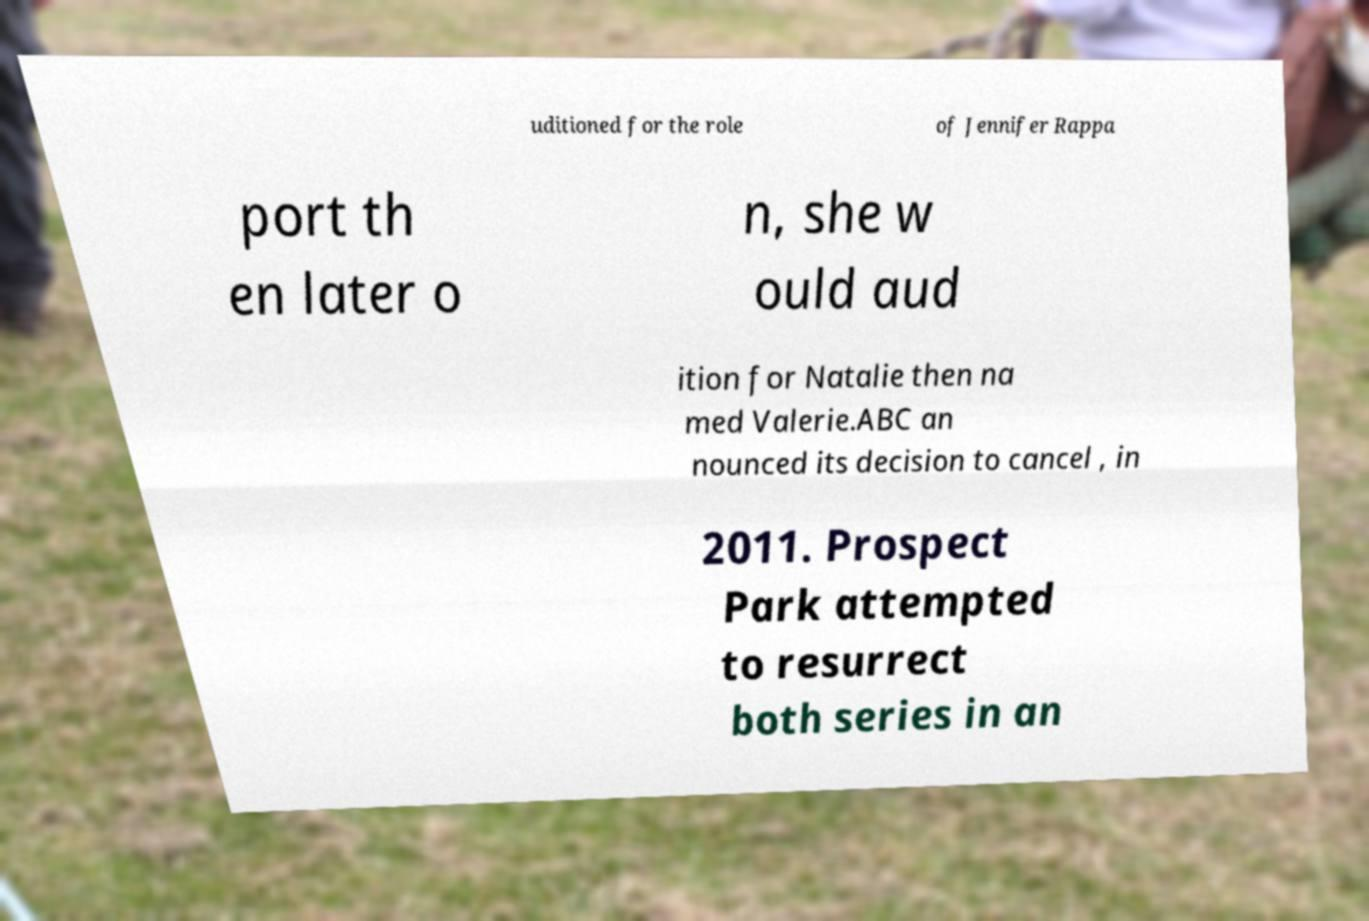I need the written content from this picture converted into text. Can you do that? uditioned for the role of Jennifer Rappa port th en later o n, she w ould aud ition for Natalie then na med Valerie.ABC an nounced its decision to cancel , in 2011. Prospect Park attempted to resurrect both series in an 